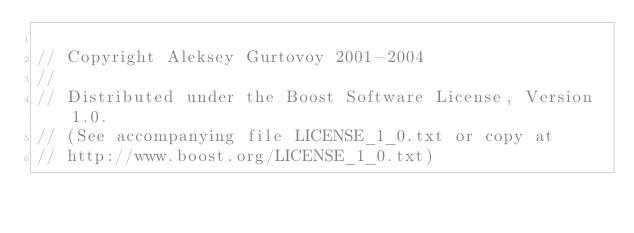Convert code to text. <code><loc_0><loc_0><loc_500><loc_500><_C++_>
// Copyright Aleksey Gurtovoy 2001-2004
//
// Distributed under the Boost Software License, Version 1.0. 
// (See accompanying file LICENSE_1_0.txt or copy at 
// http://www.boost.org/LICENSE_1_0.txt)</code> 